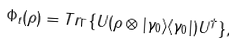Convert formula to latex. <formula><loc_0><loc_0><loc_500><loc_500>\Phi _ { t } ( \rho ) = T r _ { \Gamma } \{ U ( \rho \otimes | \gamma _ { 0 } \rangle \langle \gamma _ { 0 } | ) U ^ { \dagger } \} ,</formula> 